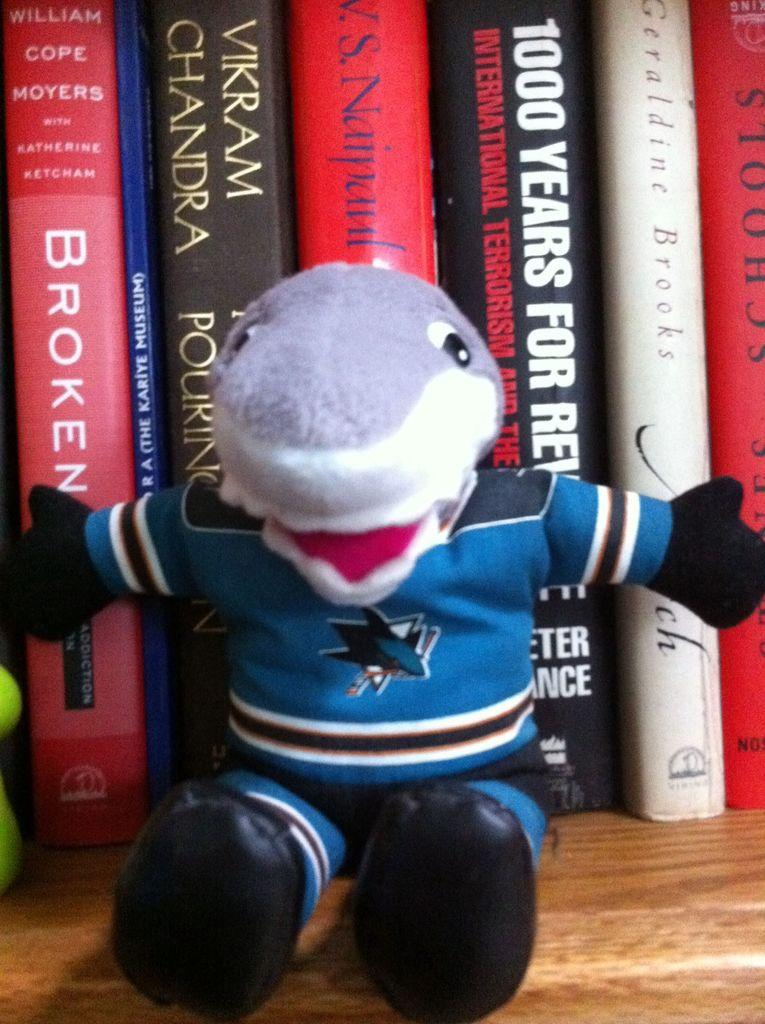<image>
Provide a brief description of the given image. a shark is in front of a book with 1000 years written on it 